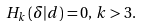Convert formula to latex. <formula><loc_0><loc_0><loc_500><loc_500>H _ { k } \left ( \delta | d \right ) = 0 , \, k > 3 .</formula> 